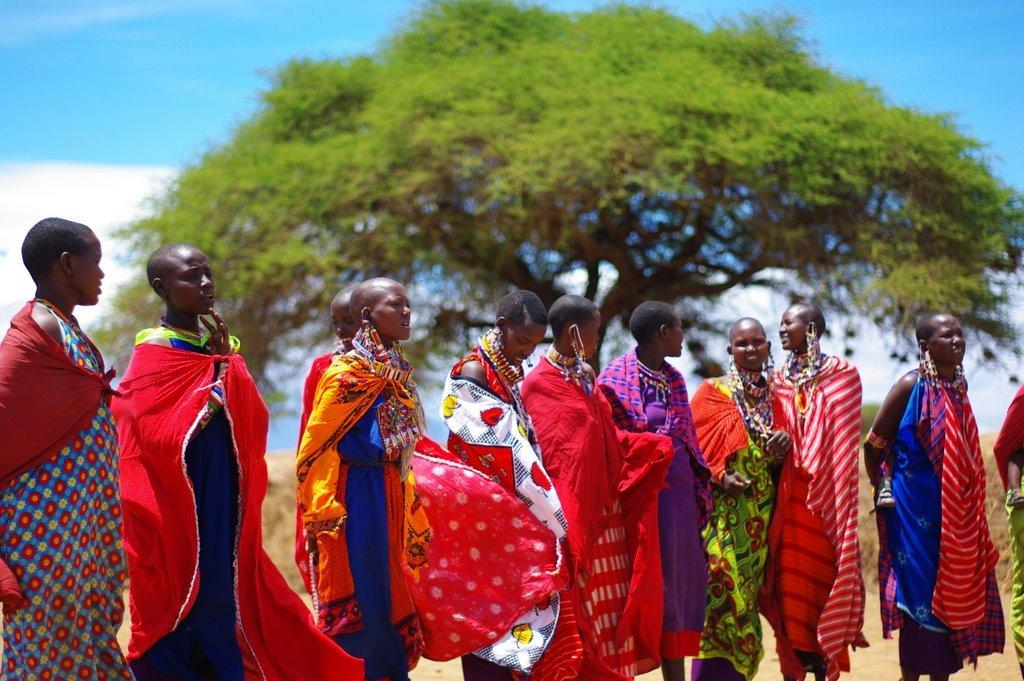What is the main subject of the image? The main subject of the image is a group of people. How are the people in the image positioned? The people are standing from left to right. What can be seen in the background of the image? There is a tree in the background of the image. How would you describe the sky in the image? The sky is blue and cloudy in the image. How many grapes are being held by the girls in the image? There are no girls or grapes present in the image. 